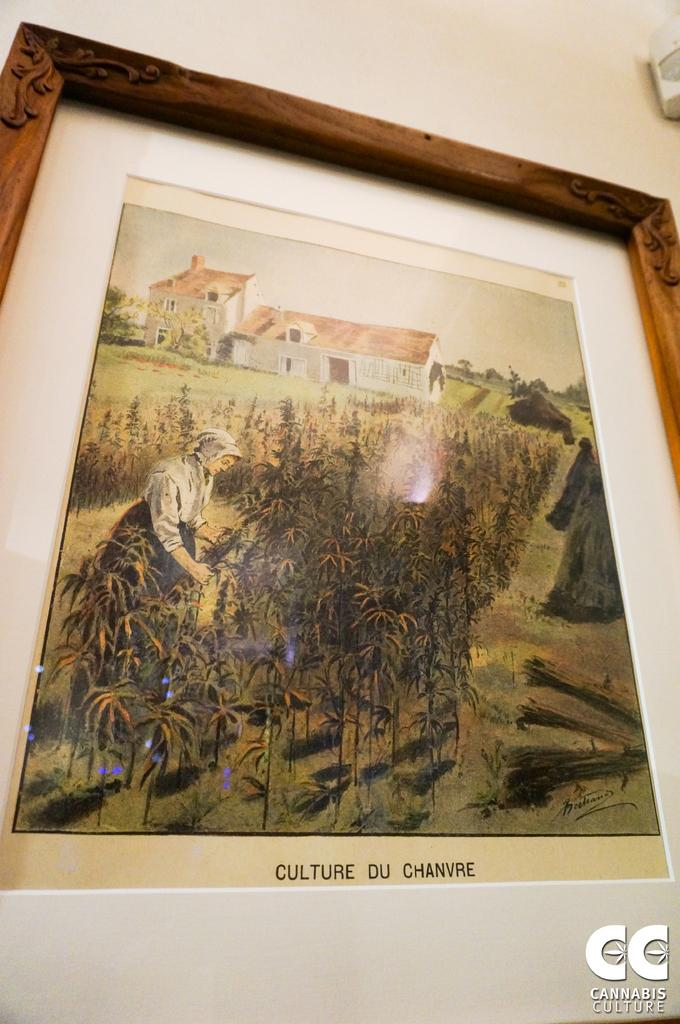<image>
Create a compact narrative representing the image presented. A framed piece of artwork showing a woman in a field named Culture Du Chanvre. 